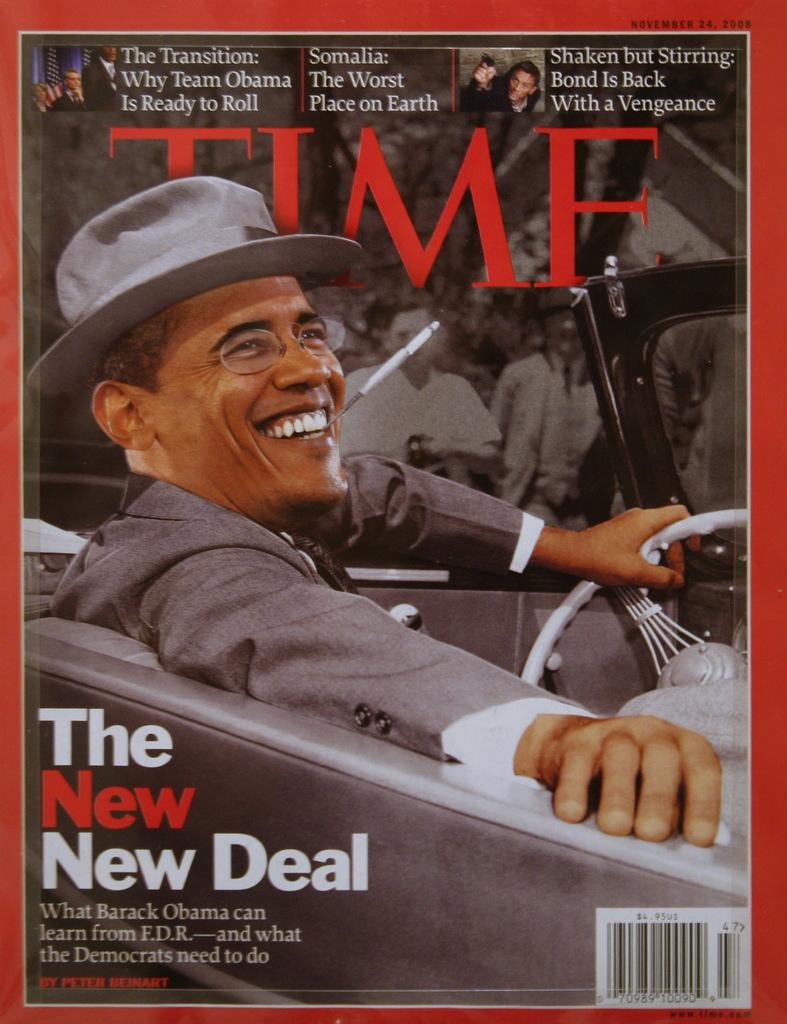What is the name of the magazine?
Ensure brevity in your answer.  Time. 